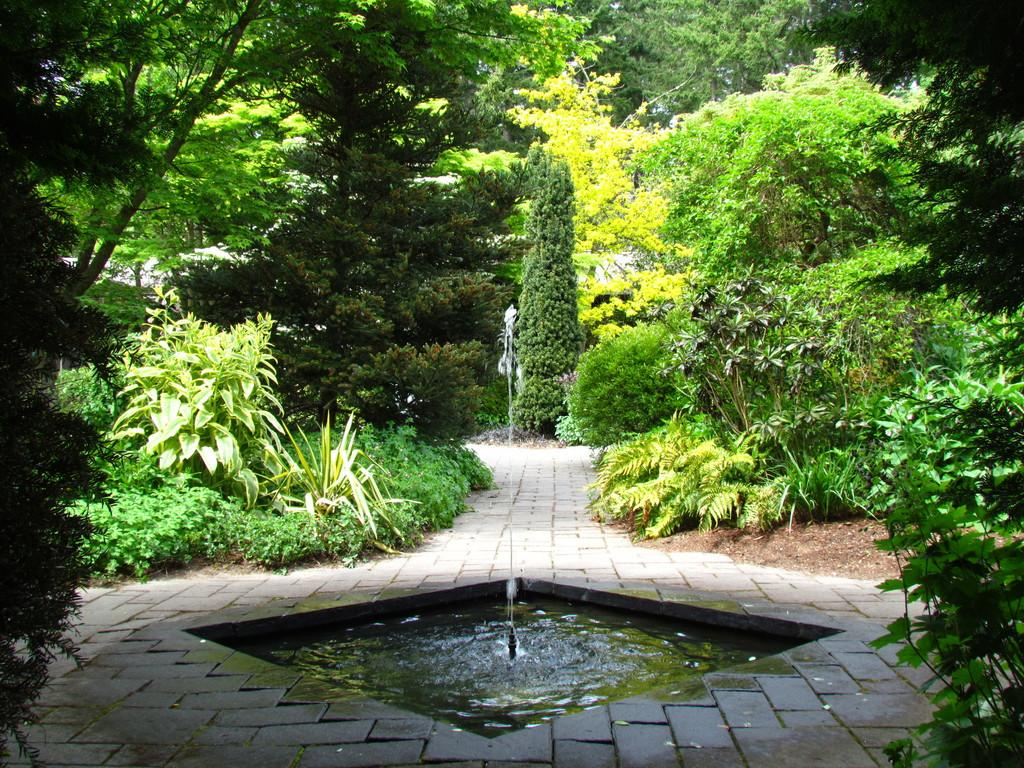What is the main feature in the center of the image? There is a small water fountain in the center of the image. What can be seen in the background of the image? There are trees visible in the background of the image. How many laborers are working on the lumber in the image? There are no laborers or lumber present in the image; it features a small water fountain and trees in the background. 